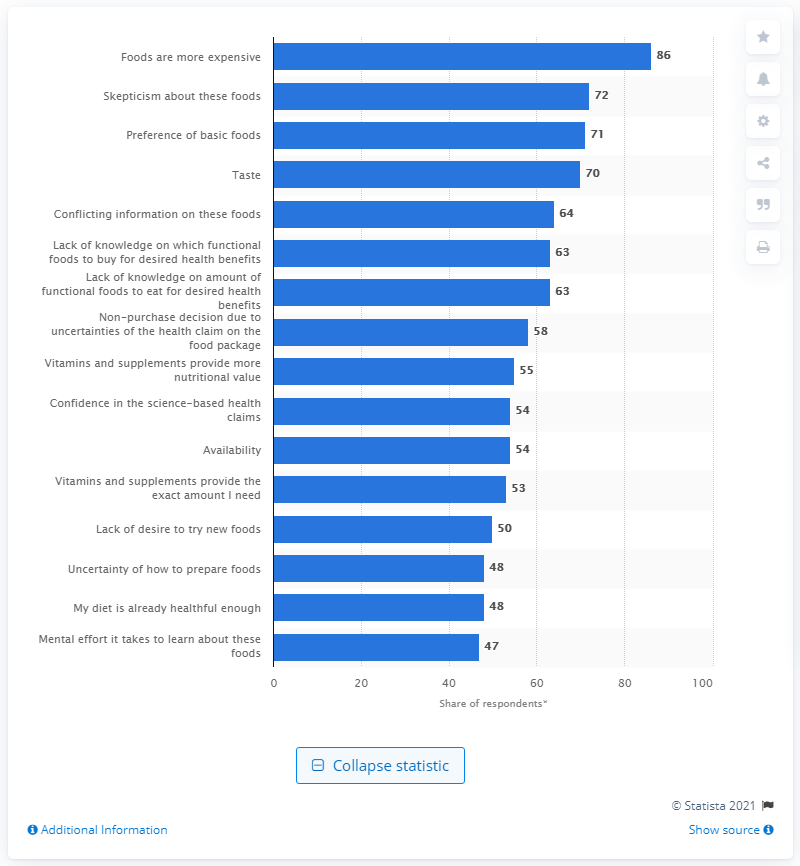Identify some key points in this picture. According to the survey results, 54% of respondents rated 'Availability' as a major or minor barrier that prevented them from consuming functional foods. 